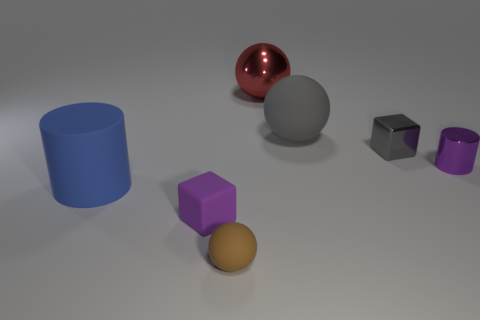Add 2 yellow matte cubes. How many objects exist? 9 Subtract all cylinders. How many objects are left? 5 Add 5 small purple rubber objects. How many small purple rubber objects are left? 6 Add 7 large cyan matte spheres. How many large cyan matte spheres exist? 7 Subtract 0 cyan spheres. How many objects are left? 7 Subtract all blue rubber cylinders. Subtract all cylinders. How many objects are left? 4 